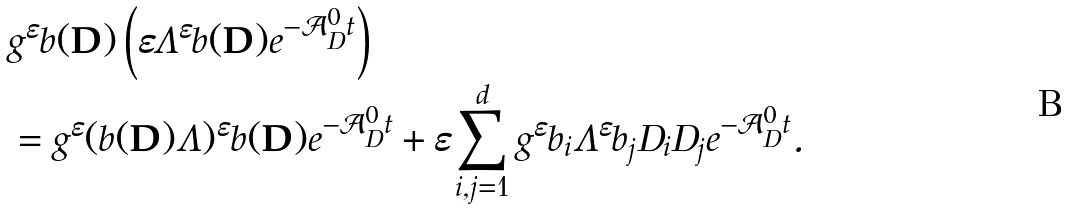Convert formula to latex. <formula><loc_0><loc_0><loc_500><loc_500>& g ^ { \varepsilon } b ( { \mathbf D } ) \left ( \varepsilon \Lambda ^ { \varepsilon } b ( { \mathbf D } ) e ^ { - \mathcal { A } _ { D } ^ { 0 } t } \right ) \\ & = g ^ { \varepsilon } ( b ( { \mathbf D } ) \Lambda ) ^ { \varepsilon } b ( { \mathbf D } ) e ^ { - \mathcal { A } _ { D } ^ { 0 } t } + \varepsilon \sum _ { i , j = 1 } ^ { d } g ^ { \varepsilon } b _ { i } \Lambda ^ { \varepsilon } b _ { j } D _ { i } D _ { j } e ^ { - \mathcal { A } _ { D } ^ { 0 } t } .</formula> 